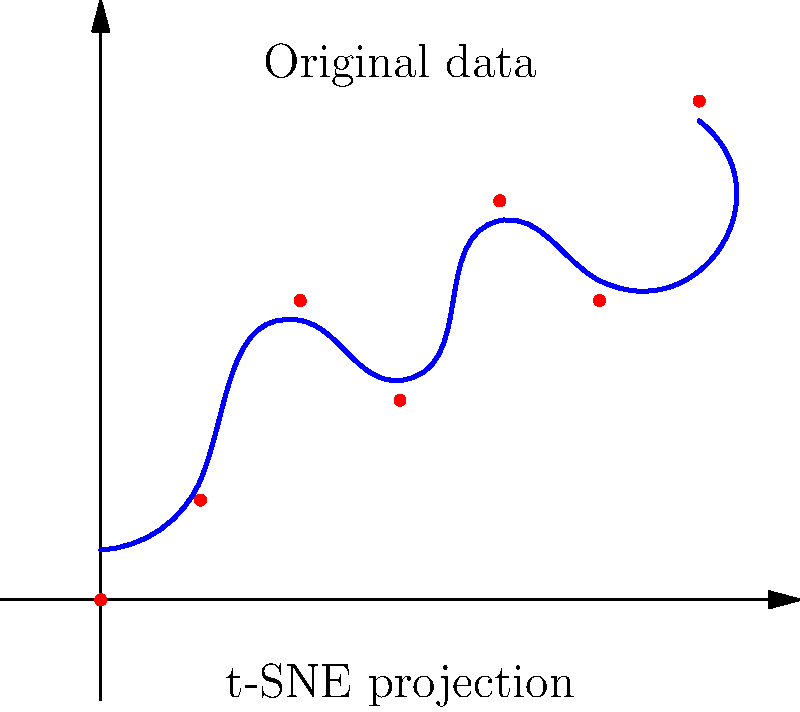In the context of visualizing multidimensional data using t-SNE (t-Distributed Stochastic Neighbor Embedding), what is the primary purpose of the perplexity parameter, and how does it affect the visualization shown in the graph above? To understand the role of the perplexity parameter in t-SNE and its effect on the visualization:

1. Definition of perplexity:
   Perplexity is a measure of the effective number of neighbors each point has in the high-dimensional space.

2. Mathematical representation:
   Perplexity is defined as $2^H$, where $H$ is the Shannon entropy of the probability distribution over neighbors:
   $$H = -\sum_{j} p_{j|i} \log_2 p_{j|i}$$

3. Function of perplexity:
   - It balances local and global aspects of the data.
   - It determines the number of nearest neighbors to consider when preserving local structures.

4. Effect on visualization:
   - Low perplexity: Focuses on local structures, potentially missing global patterns.
   - High perplexity: Preserves more global structure but may lose fine details.

5. In the given visualization:
   - The blue curve represents the t-SNE projection of the original red data points.
   - Different perplexity values would result in different curvatures of the blue line.
   - A lower perplexity might result in a more tightly curved line, emphasizing local relationships.
   - A higher perplexity might produce a smoother, more globally representative curve.

6. Choosing perplexity:
   - Typically ranges from 5 to 50.
   - Needs to be tuned based on the dataset size and dimensionality.
   - For this web developer scenario, they might experiment with different perplexity values to find the best representation of their multidimensional web traffic or user behavior data.

7. Impact on clustering:
   - Perplexity affects how points cluster in the lower-dimensional space.
   - It can influence the separation between different groups of data points.

8. Computational considerations:
   - Higher perplexity values increase computational complexity.
   - Web developers working with large datasets need to balance accuracy and performance.
Answer: Perplexity controls the balance between preserving local and global data structures in t-SNE visualization, affecting the curvature and clustering of the projected data. 